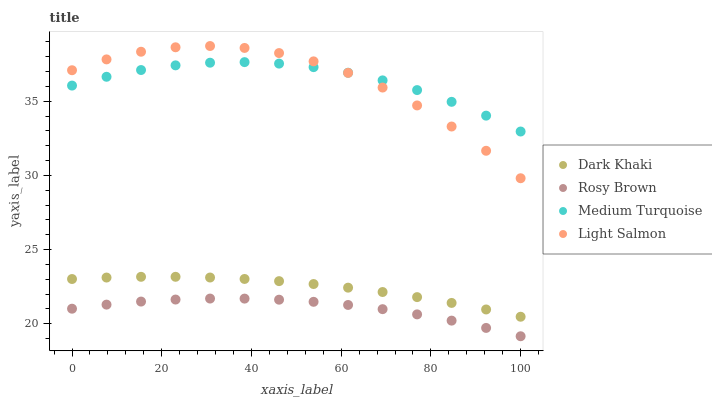Does Rosy Brown have the minimum area under the curve?
Answer yes or no. Yes. Does Light Salmon have the maximum area under the curve?
Answer yes or no. Yes. Does Light Salmon have the minimum area under the curve?
Answer yes or no. No. Does Rosy Brown have the maximum area under the curve?
Answer yes or no. No. Is Dark Khaki the smoothest?
Answer yes or no. Yes. Is Light Salmon the roughest?
Answer yes or no. Yes. Is Rosy Brown the smoothest?
Answer yes or no. No. Is Rosy Brown the roughest?
Answer yes or no. No. Does Rosy Brown have the lowest value?
Answer yes or no. Yes. Does Light Salmon have the lowest value?
Answer yes or no. No. Does Light Salmon have the highest value?
Answer yes or no. Yes. Does Rosy Brown have the highest value?
Answer yes or no. No. Is Rosy Brown less than Light Salmon?
Answer yes or no. Yes. Is Medium Turquoise greater than Rosy Brown?
Answer yes or no. Yes. Does Light Salmon intersect Medium Turquoise?
Answer yes or no. Yes. Is Light Salmon less than Medium Turquoise?
Answer yes or no. No. Is Light Salmon greater than Medium Turquoise?
Answer yes or no. No. Does Rosy Brown intersect Light Salmon?
Answer yes or no. No. 